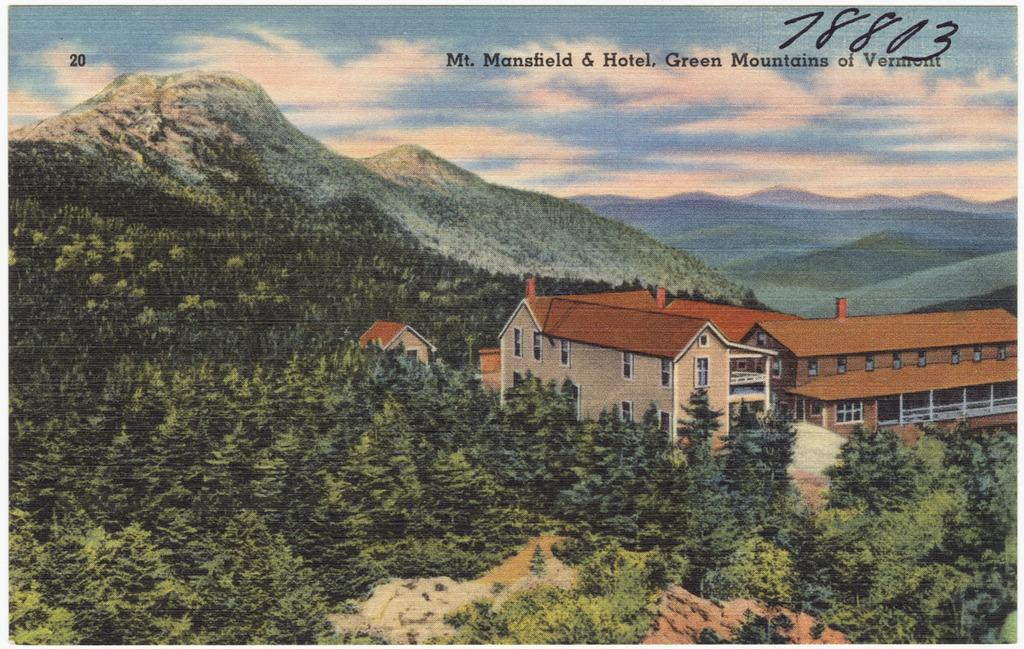What type of structures are visible in the image? There are buildings with windows in the image. What other natural elements can be seen in the image? There are trees and mountains in the image. What is visible in the background of the image? The sky is visible in the background of the image. What can be observed in the sky? Clouds are present in the sky. Who is the owner of the mountains in the image? There is no indication of ownership in the image, and mountains do not have owners. 